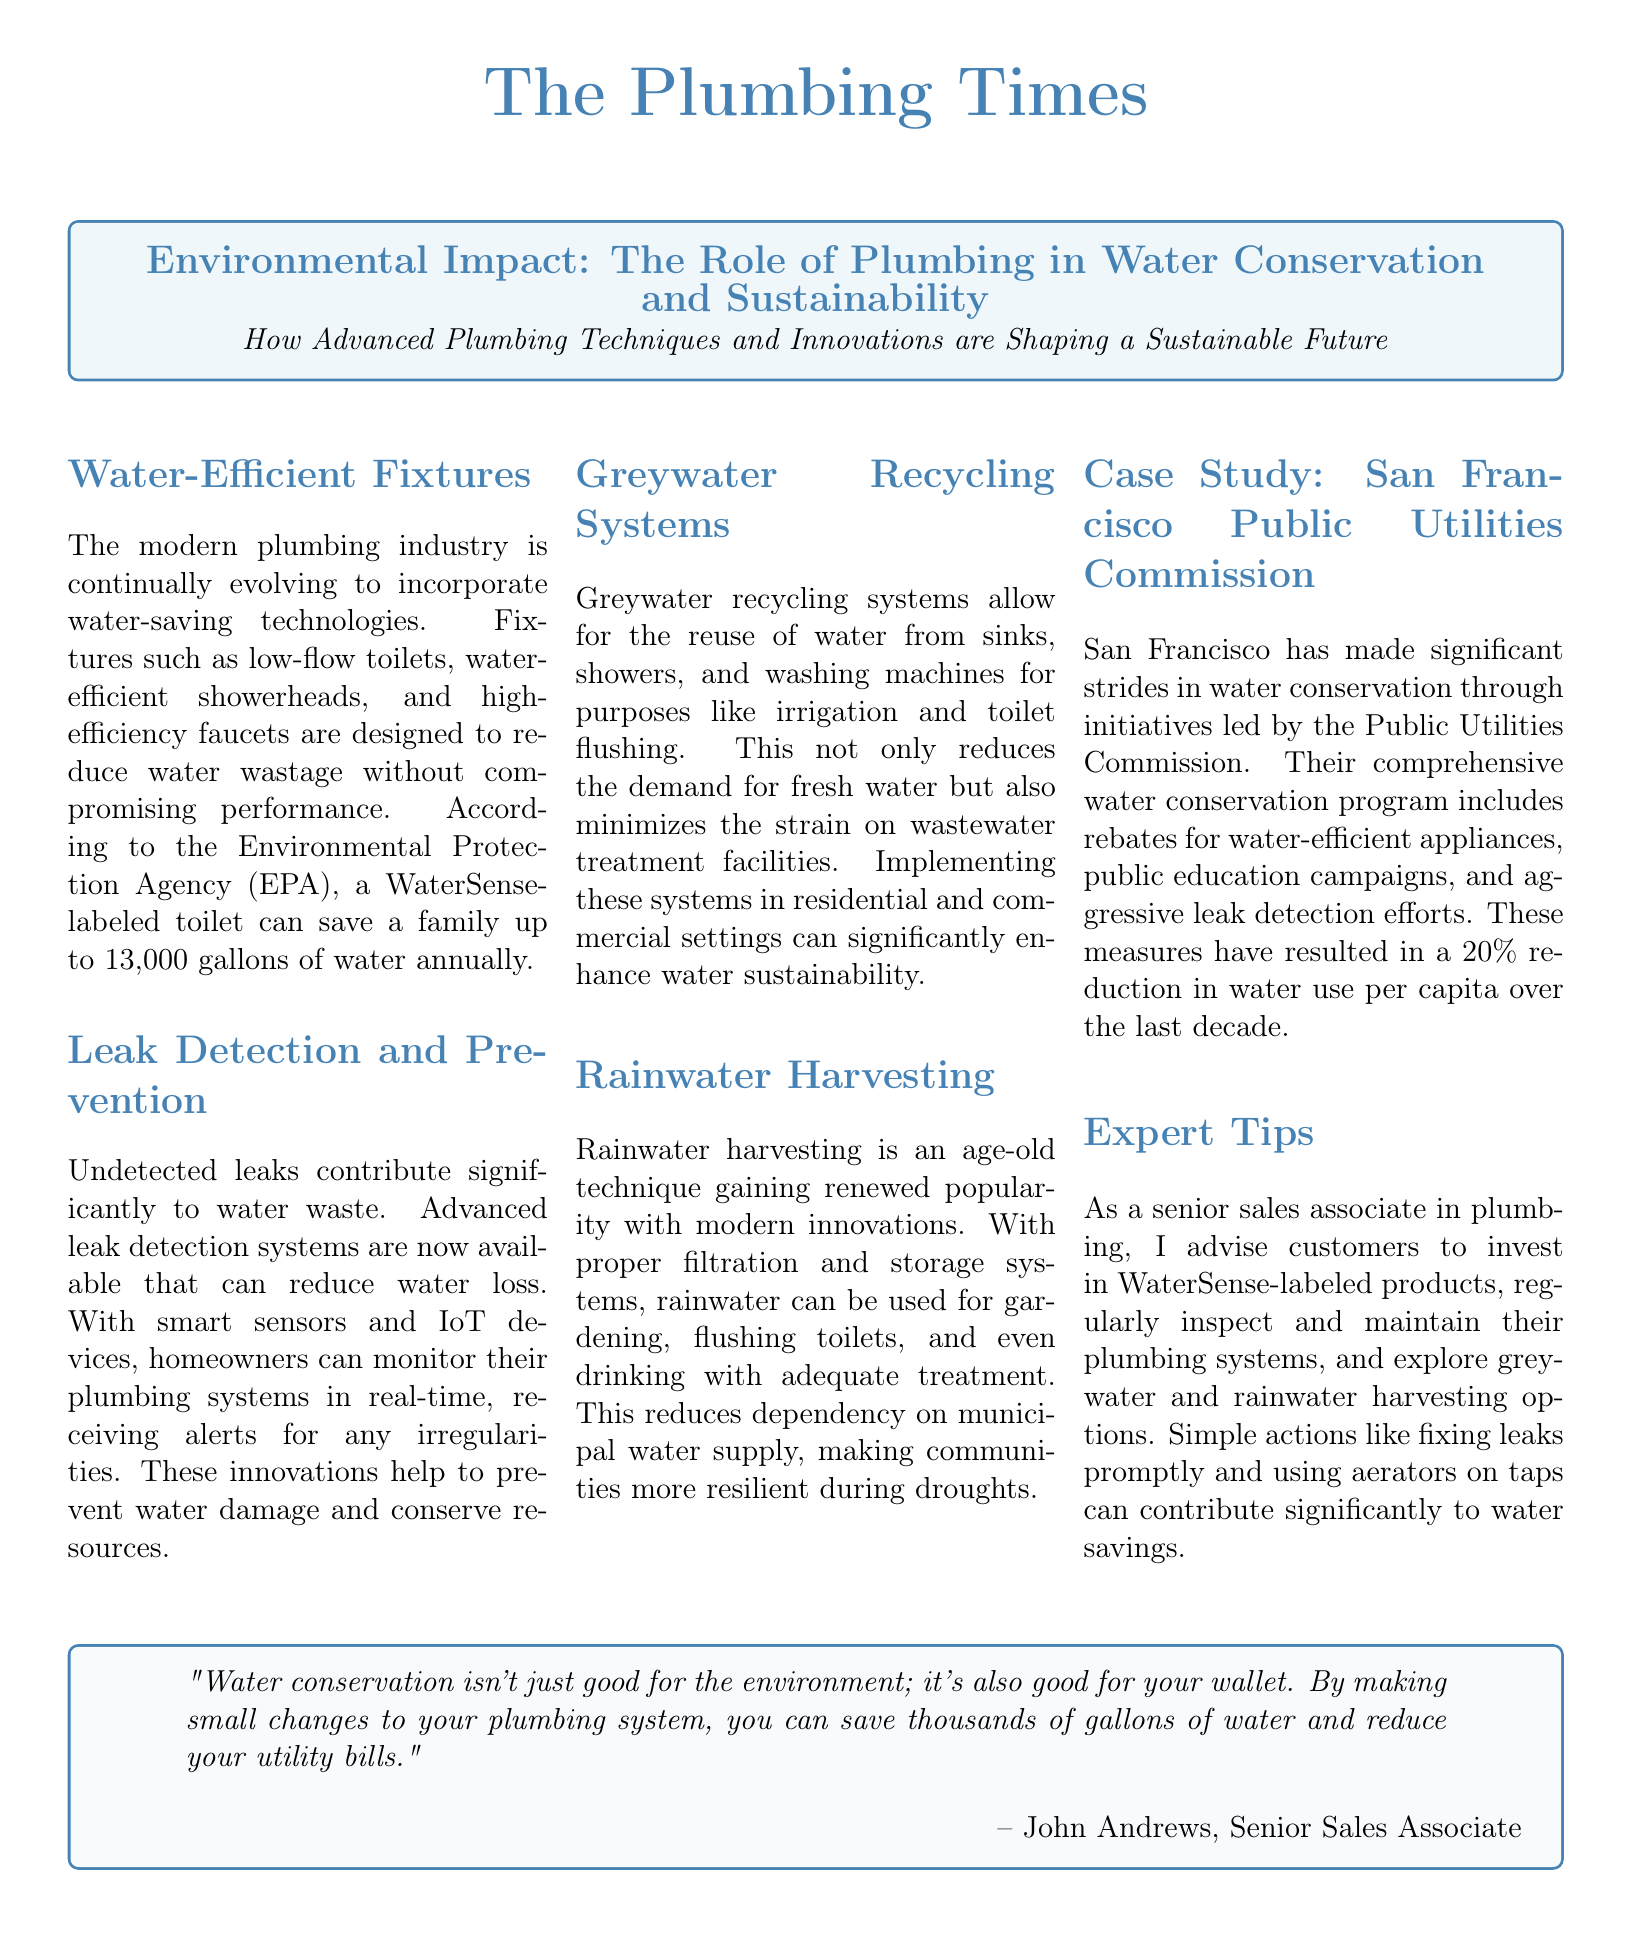What is the title of the article? The title of the article is the main headline presented at the top of the document.
Answer: The Plumbing Times What is a WaterSense-labeled toilet's annual water saving potential? According to the EPA, it can save a family significant gallons of water annually, specified in the document.
Answer: 13,000 gallons What technology assists in reducing water loss from leaks? The document discusses advanced systems and technologies that help in water conservation, specifically referring to specific devices.
Answer: Smart sensors and IoT devices How much has San Francisco reduced water use per capita over the last decade? This figure is provided as part of a case study discusses water conservation efforts in the city.
Answer: 20% What is one way to reuse water mentioned in the document? The document lists various methods of water sustainability, reflecting on certain systems that enhance water conservation efforts.
Answer: Greywater recycling systems What is the benefit of small changes in plumbing systems according to John Andrews? This quote highlights the broader implications of water conservation efforts in personal finance as well as environmental impact.
Answer: Save thousands of gallons of water What type of initiatives does the San Francisco Public Utilities Commission lead? The document outlines the nature of the programs initiated by the commission focused on water efficiency.
Answer: Water conservation program What is one expert tip for customers mentioned in the document? One action recommended by the senior sales associate for better plumbing practices can significantly impact water savings.
Answer: Invest in WaterSense-labeled products 